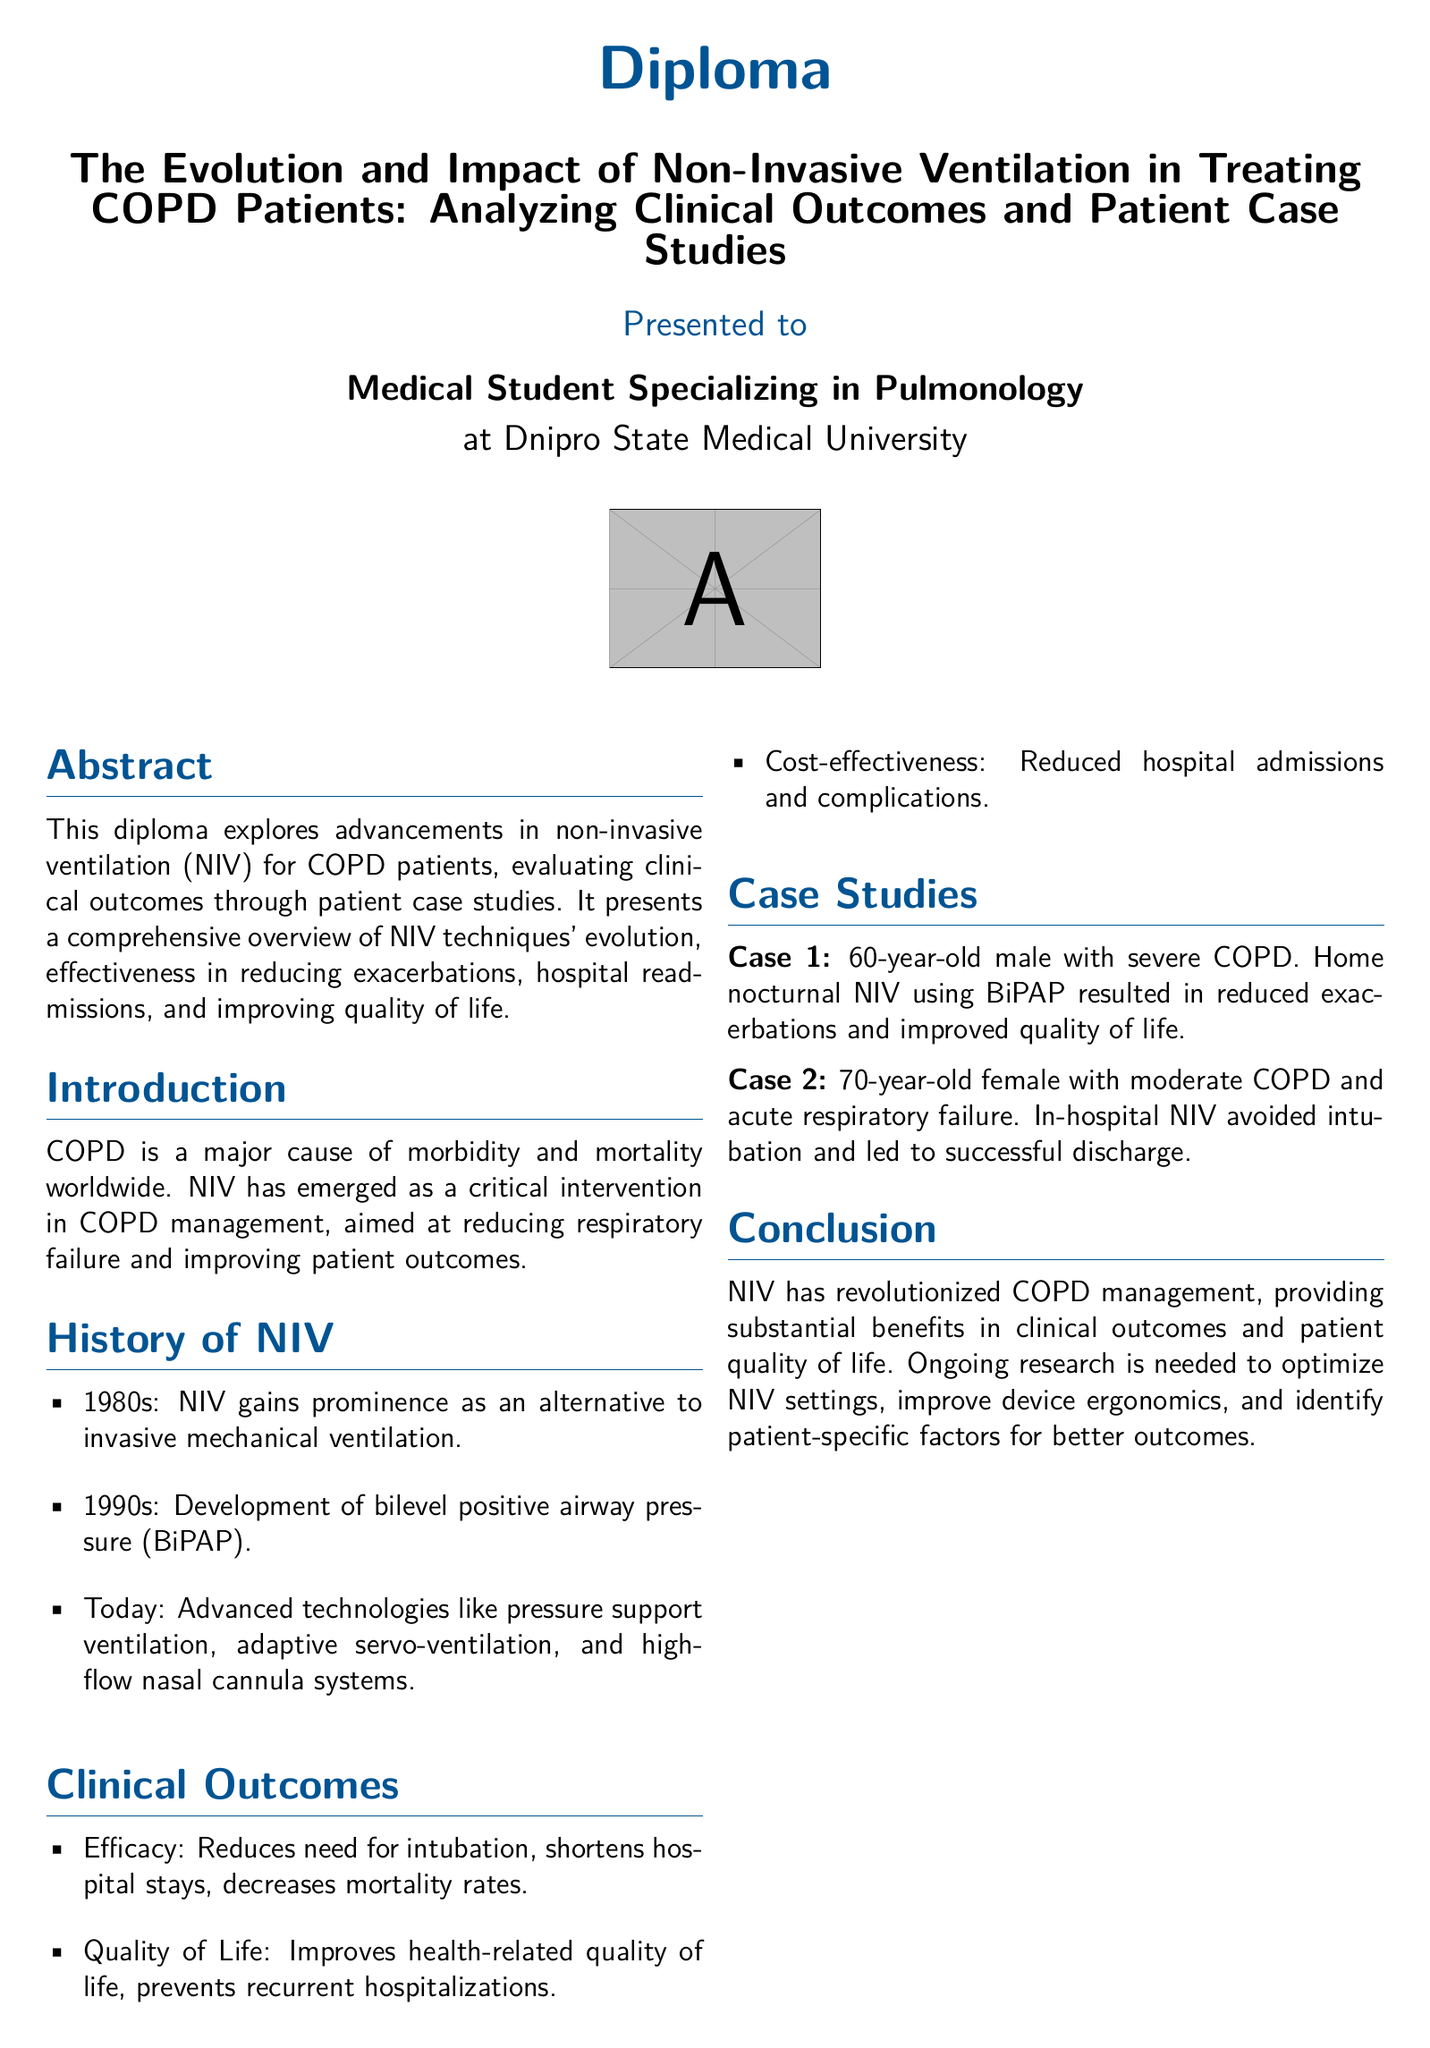What is the title of the diploma? The title can be found in the first section of the document, which clearly states the subject of the diploma.
Answer: The Evolution and Impact of Non-Invasive Ventilation in Treating COPD Patients: Analyzing Clinical Outcomes and Patient Case Studies What is the stated aim of non-invasive ventilation (NIV) for COPD patients? The aim is mentioned in the introduction and focuses on the goals of NIV in managing COPD patients.
Answer: Reducing respiratory failure and improving patient outcomes In what decade did NIV gain prominence? The timeline provided in the history section indicates the rise of NIV in a specific decade.
Answer: 1980s Which technique was developed in the 1990s? This information is specified in the history section, detailing advancements in NIV techniques.
Answer: Bilevel positive airway pressure (BiPAP) What was the outcome for the 60-year-old male with severe COPD using BiPAP? The case study summarizes the benefits experienced by this patient through NIV treatment.
Answer: Reduced exacerbations and improved quality of life How did in-hospital NIV affect the 70-year-old female with acute respiratory failure? The outcome for this patient is described in a case study, illustrating the intervention's effectiveness.
Answer: Avoided intubation and led to successful discharge What is one clinical outcome of NIV mentioned in the document? The clinical outcomes outlined in the document provide various benefits associated with NIV treatment.
Answer: Reduces need for intubation Who are the authors of one of the key references? The references section includes studies authored by specific individuals relevant to the topic discussed.
Answer: Nava S, et al What is a key benefit of NIV regarding hospital admissions? The document lists advantages of NIV related to healthcare resource utilization.
Answer: Reduced hospital admissions and complications 